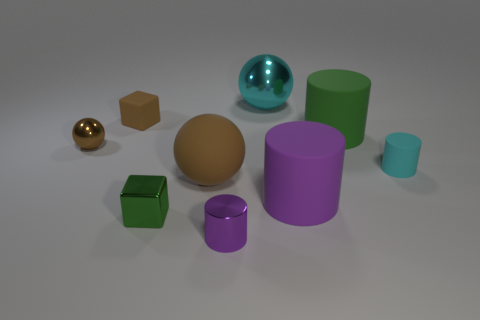Can you describe the texture and overall appearance of the spherical objects in the image? Certainly! There are two spherical objects in the image. The larger one has a matte golden surface that looks quite smooth, and it exudes a subtle warmth. The smaller sphere has a reflective turquoise surface, gleaming as if it's made of glass or polished metal, with highlights indicating a bright light source. 